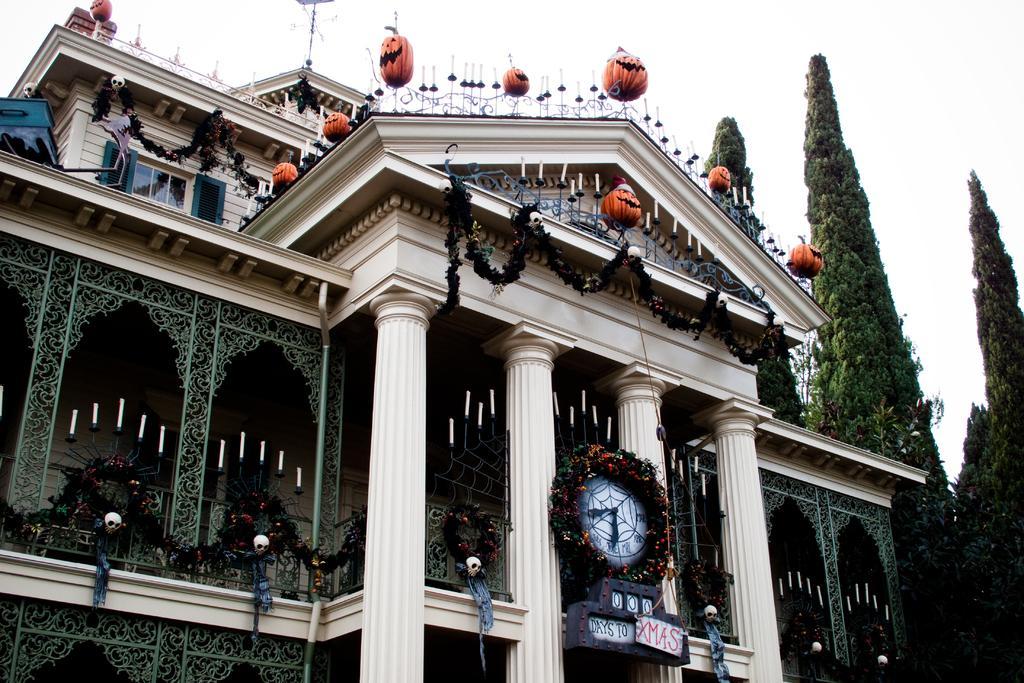Describe this image in one or two sentences. In this picture we can see a clock on the building, in the background we can find few trees, and also we can see few metal rods. 